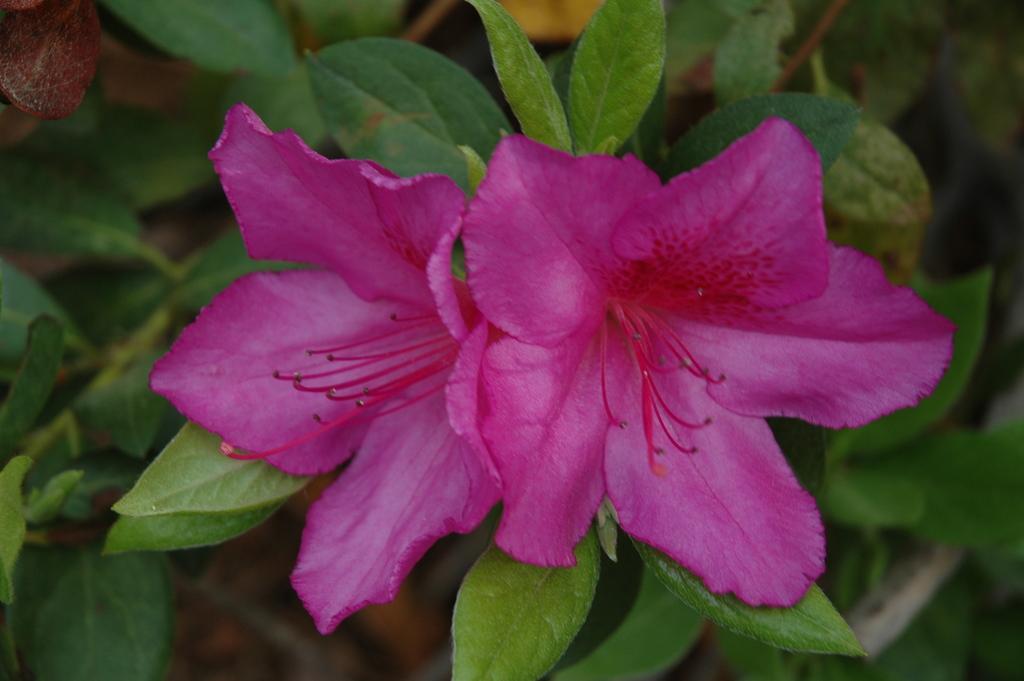Can you describe this image briefly? In this image I can see few pink color flowers and few green color leaves. Background is blurred. 